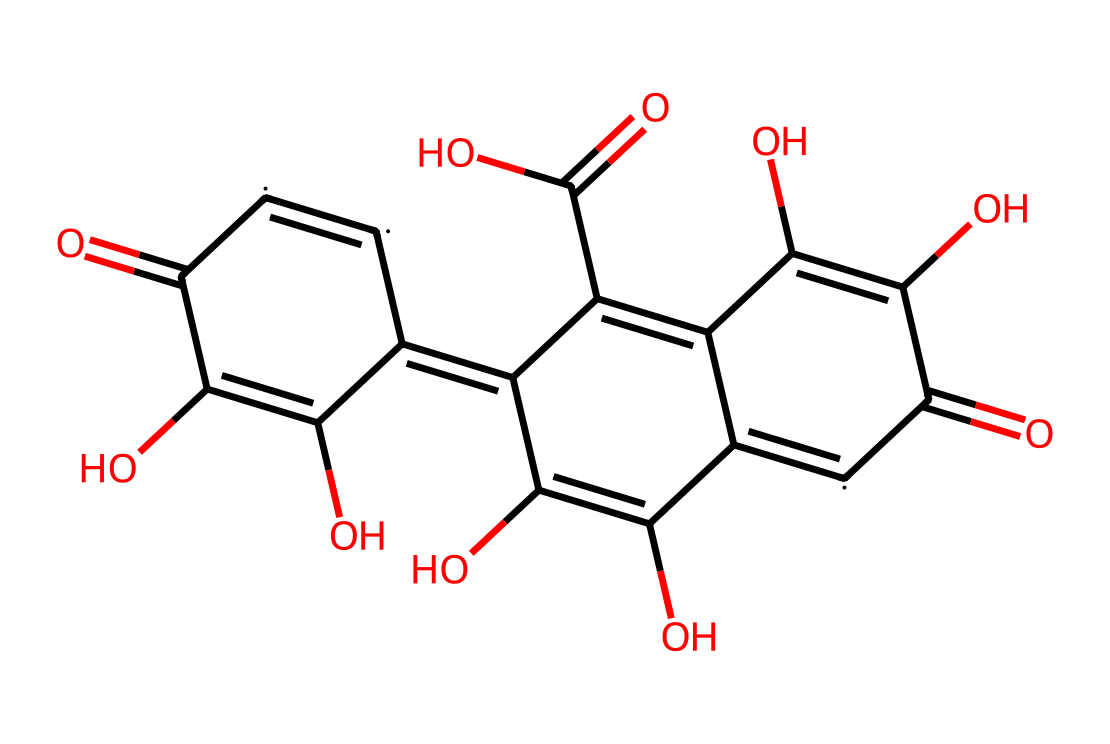What is the primary functional group observed in this molecule? The molecule contains hydroxyl (-OH) groups which indicate the presence of alcohols. These can be seen at several positions in the structure where oxygen is bonded to hydrogen.
Answer: hydroxyl How many carbon atoms are present in the structure? By counting the carbon atoms represented in the SMILES string, you can determine the total. There are twelve representations of "[C]" throughout the structure, meaning there are twelve carbon atoms in total.
Answer: twelve What type of bonding is primarily present in this chemical? The chemical shows a combination of double bonds, particularly between carbon and oxygen. This is visible from the "=" symbols connecting carbon and oxygen atoms.
Answer: double bonds Which part of this chemical contributes to its electrical conductivity? Graphene oxide has a high degree of carbon atoms in a hexagonal structure that facilitates electron mobility, while functional groups like hydroxyl can be crucial for environmental interaction.
Answer: hexagonal structure What is the molecular weight of this compound? To calculate the molecular weight, you need to consider the atomic weights of all atoms represented (C, O, H) in the molecular structure. By summing the contributions from twelve carbons, ten oxygens, and ten hydrogens, the total can be determined. The total molecular weight here is approximately 264.
Answer: 264 How many hydroxyl groups are identified in this structure? By analyzing the SMILES representation, you can identify hydroxyl groups in the molecule. Each occurrence of "O" that is bonded to a "C" indicates the presence of a hydroxyl group. There are a total of four "O" elements connected directly to carbon atoms.
Answer: four What is the significance of the carbonyl groups in the structure? Carbonyl groups (C=O) are important for reactivity and participate in functionalization and modification processes. In this structure, the presence of carbonyls signifies potential sites for chemical reactions, which is essential for sensor functionality.
Answer: reactivity 